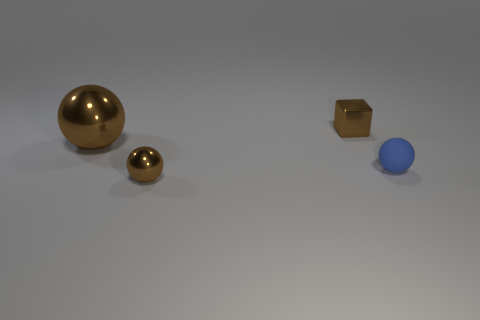Do the brown ball that is in front of the large metal thing and the big object have the same material?
Offer a terse response. Yes. How many spheres are big gray metal things or brown metal things?
Your response must be concise. 2. There is a tiny metal object to the left of the metallic cube right of the metal sphere that is behind the small blue sphere; what shape is it?
Make the answer very short. Sphere. What shape is the small metallic object that is the same color as the metal cube?
Provide a succinct answer. Sphere. How many brown blocks have the same size as the blue matte sphere?
Make the answer very short. 1. There is a small metallic thing in front of the big brown object; is there a metallic object that is to the left of it?
Make the answer very short. Yes. How many objects are either large cyan rubber balls or small brown things?
Ensure brevity in your answer.  2. There is a tiny shiny thing in front of the brown metal ball that is to the left of the tiny ball on the left side of the small brown shiny block; what color is it?
Provide a short and direct response. Brown. Are there any other things of the same color as the big thing?
Offer a very short reply. Yes. What number of objects are either tiny things in front of the tiny brown shiny cube or rubber balls that are in front of the metallic block?
Your response must be concise. 2. 